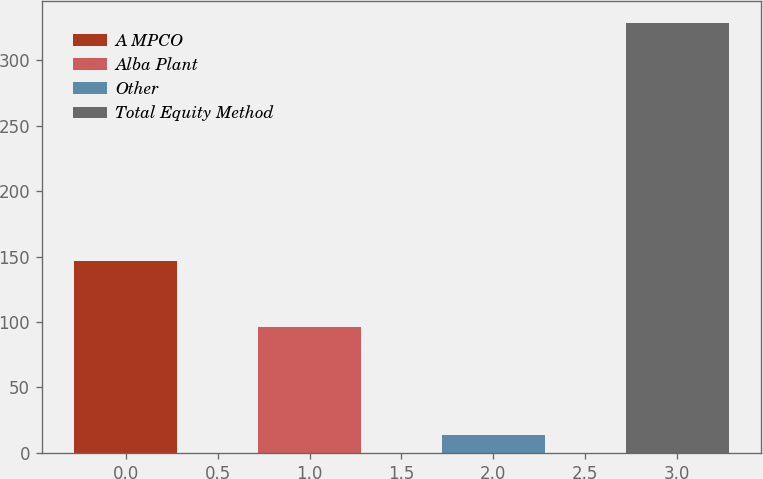<chart> <loc_0><loc_0><loc_500><loc_500><bar_chart><fcel>A MPCO<fcel>Alba Plant<fcel>Other<fcel>Total Equity Method<nl><fcel>147<fcel>96<fcel>14<fcel>329<nl></chart> 